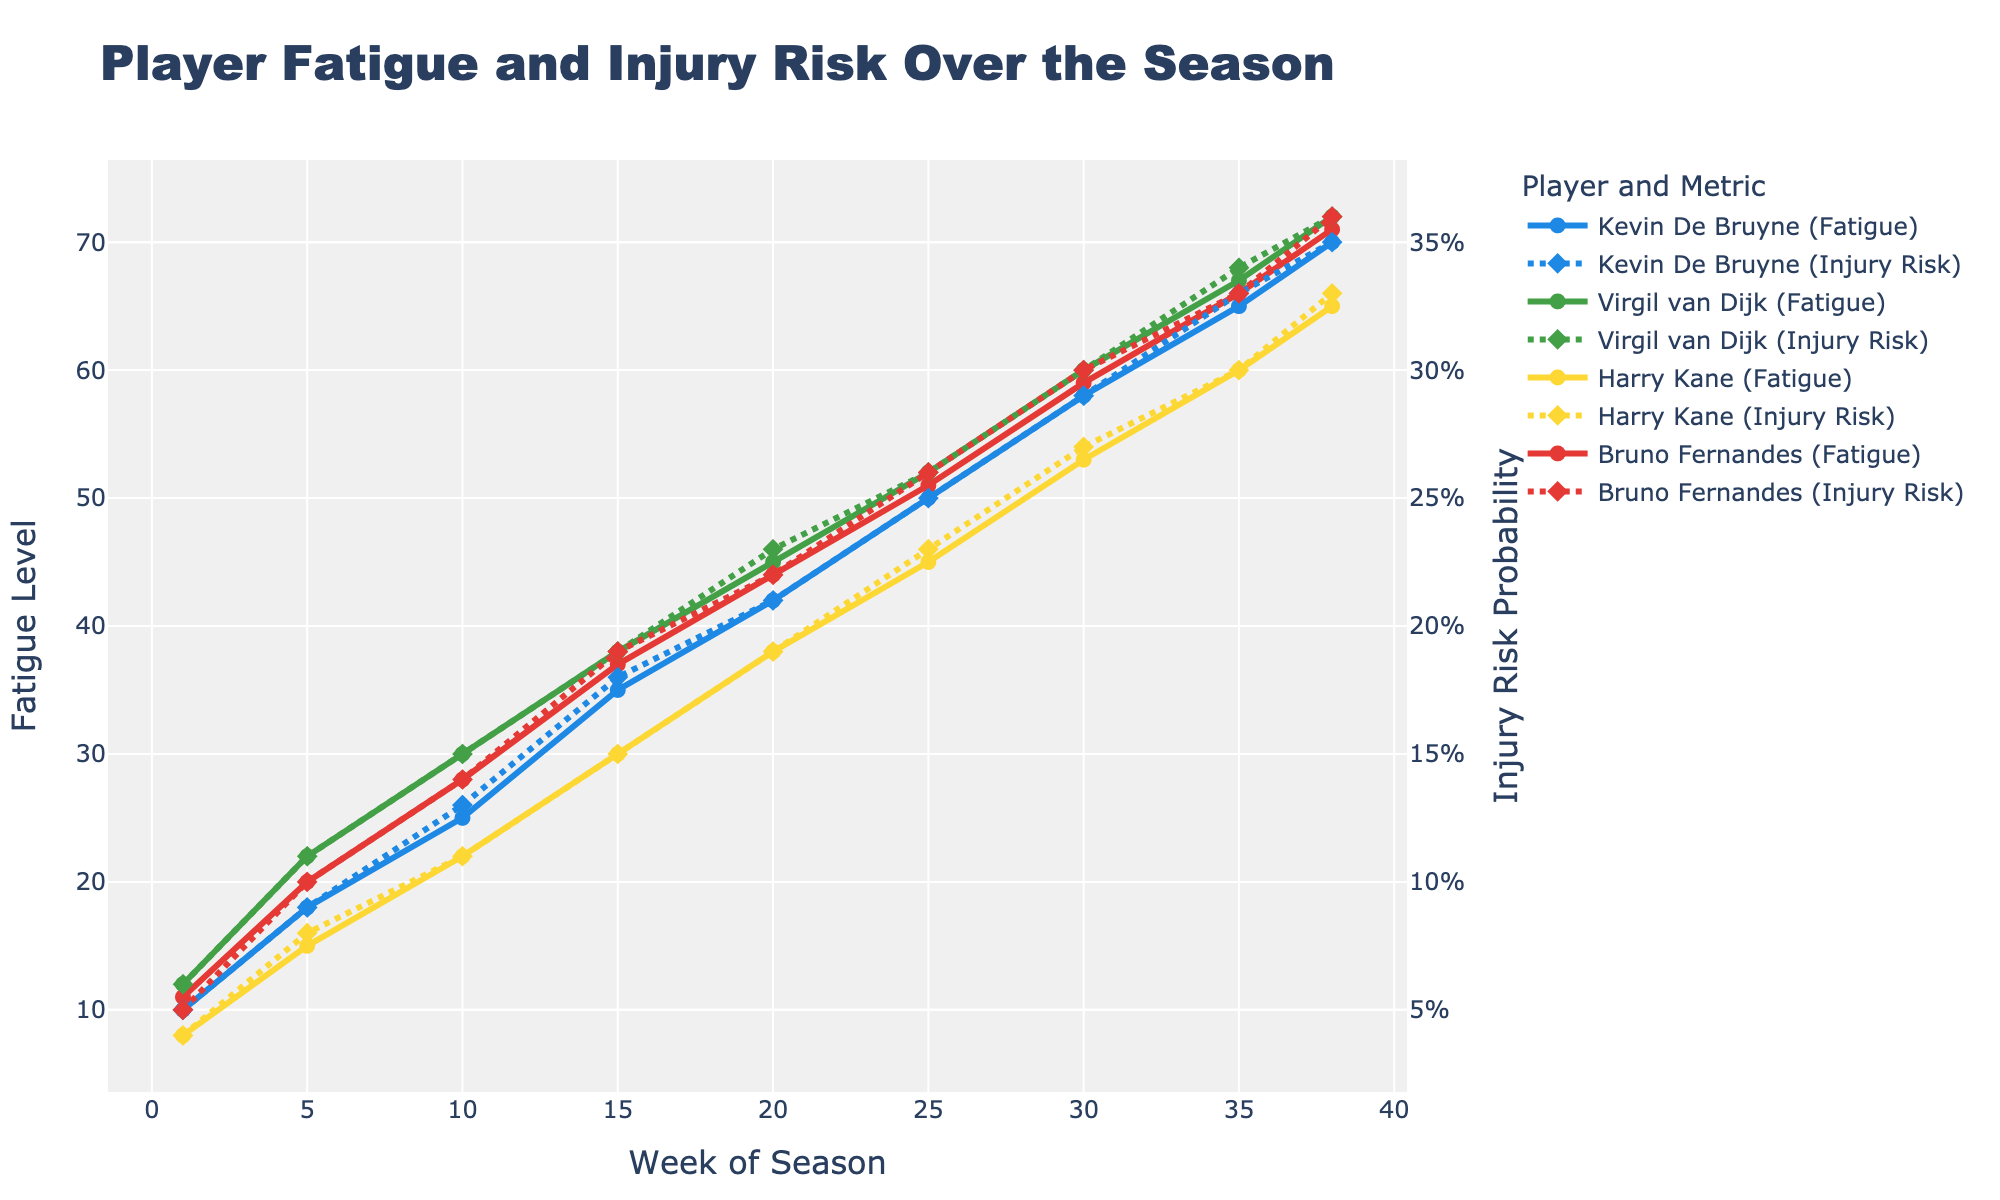What is the Fatigue Level of Harry Kane at Week 10? To find Harry Kane's Fatigue Level at Week 10, locate Week 10 on the x-axis and look at the trend line for Harry Kane relevant to Fatigue Level, which corresponds to a specific y-axis value.
Answer: 22 Which player has the highest Injury Risk Probability at Week 38? At Week 38, compare the Injury Risk Probabilities of all players (indicated by the dotted lines). Identify the highest value by checking the y-axis.
Answer: Virgil van Dijk How much does Bruno Fernandes' Fatigue Level increase from Week 1 to Week 20? Calculate the difference between Bruno Fernandes' Fatigue Level at Week 1 (11) and Week 20 (44). Subtract the Week 1 value from the Week 20 value: 44 - 11.
Answer: 33 What is the average Injury Risk Probability for Kevin De Bruyne over the first 10 weeks? Identify Kevin De Bruyne's Injury Risk Probabilities at Weeks 1 (0.05), 5 (0.09), and 10 (0.13). Sum these values (0.05 + 0.09 + 0.13 = 0.27) and divide by the number of weeks (3): 0.27 / 3.
Answer: 0.09 Who has a higher Fatigue Level at Week 15, Virgil van Dijk or Bruno Fernandes? Compare the Fatigue Levels of Virgil van Dijk (38) and Bruno Fernandes (37) at Week 15 by checking their respective trend lines.
Answer: Virgil van Dijk How does the Injury Risk Probability of Harry Kane change from Week 25 to Week 30? Note Harry Kane's Injury Risk at Weeks 25 (0.23) and 30 (0.27). Calculate the difference: 0.27 - 0.23.
Answer: 0.04 Which two players have equal Injury Risk Probabilities at Week 35? Find Injury Risk Probabilities at Week 35 and identify which players share the same value: Kevin De Bruyne (0.33) and Bruno Fernandes (0.33).
Answer: Kevin De Bruyne and Bruno Fernandes What is the total increase in Fatigue Levels for Virgil van Dijk from Week 1 to Week 35? Sum increases between weeks for Virgil van Dijk: Week 1 (12), Week 5 (22 - 12 = 10), Week 10 (30 - 22 = 8), Week 15 (38 - 30 = 8), Week 20 (45 - 38 = 7), Week 25 (52 - 45 = 7), Week 30 (60 - 52 = 8), Week 35 (67 - 60 = 7). Total is 12 + 10 + 8 + 8 + 7 + 7 + 8 + 7.
Answer: 67 Which player has the steepest increase in Fatigue Level between Weeks 10 and 15? Compare the differences in Fatigue Levels between Week 10 and Week 15 for each player: Kevin De Bruyne (35 - 25 = 10), Virgil van Dijk (38 - 30 = 8), Harry Kane (30 - 22 = 8), Bruno Fernandes (37 - 28 = 9). Kevin De Bruyne has the steepest increase of 10.
Answer: Kevin De Bruyne 